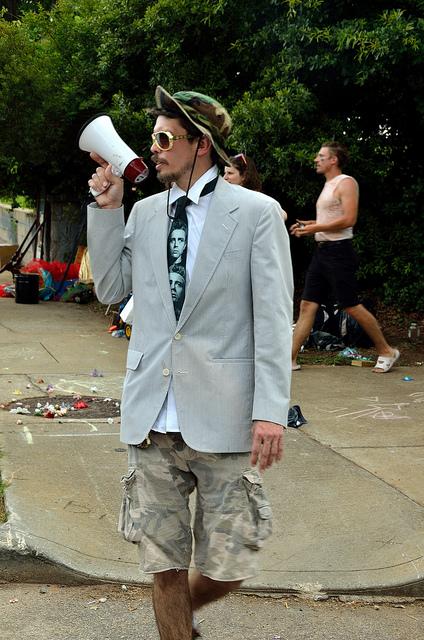Is the man happy?
Concise answer only. No. What is the man holding?
Concise answer only. Megaphone. What emotion is the man feeling?
Keep it brief. Happy. Is the man wearing jeans?
Be succinct. No. 